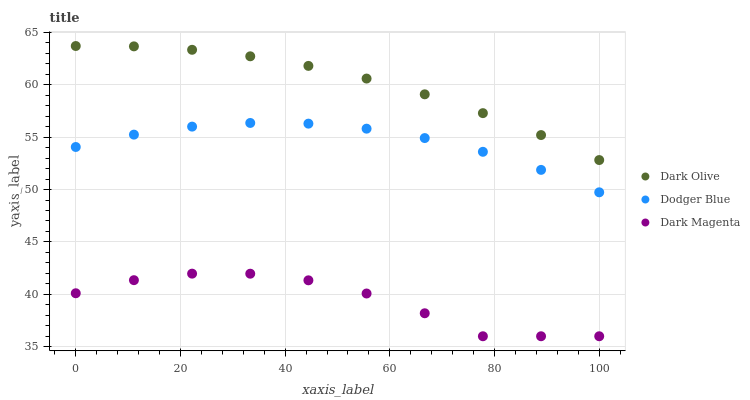Does Dark Magenta have the minimum area under the curve?
Answer yes or no. Yes. Does Dark Olive have the maximum area under the curve?
Answer yes or no. Yes. Does Dodger Blue have the minimum area under the curve?
Answer yes or no. No. Does Dodger Blue have the maximum area under the curve?
Answer yes or no. No. Is Dark Olive the smoothest?
Answer yes or no. Yes. Is Dark Magenta the roughest?
Answer yes or no. Yes. Is Dodger Blue the smoothest?
Answer yes or no. No. Is Dodger Blue the roughest?
Answer yes or no. No. Does Dark Magenta have the lowest value?
Answer yes or no. Yes. Does Dodger Blue have the lowest value?
Answer yes or no. No. Does Dark Olive have the highest value?
Answer yes or no. Yes. Does Dodger Blue have the highest value?
Answer yes or no. No. Is Dodger Blue less than Dark Olive?
Answer yes or no. Yes. Is Dodger Blue greater than Dark Magenta?
Answer yes or no. Yes. Does Dodger Blue intersect Dark Olive?
Answer yes or no. No. 